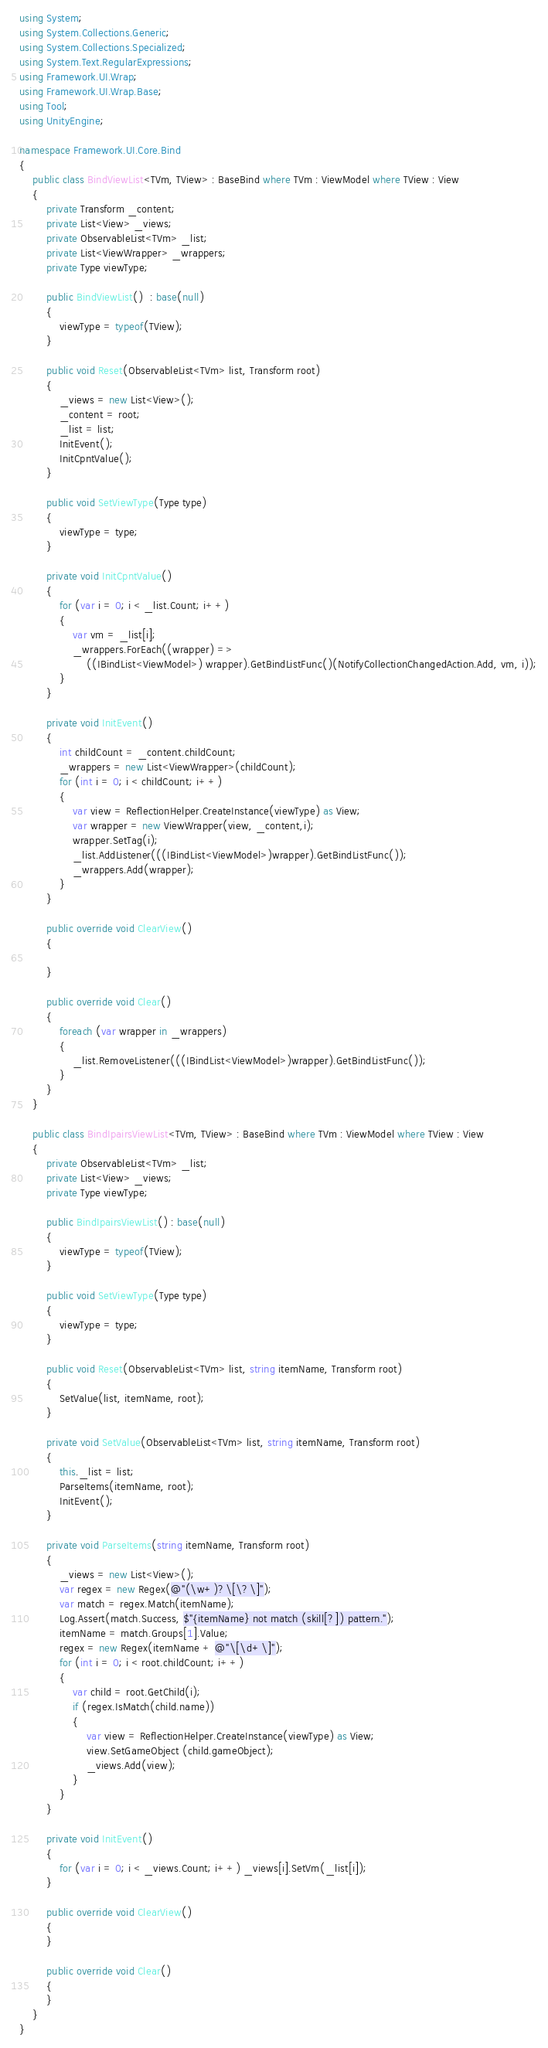<code> <loc_0><loc_0><loc_500><loc_500><_C#_>using System;
using System.Collections.Generic;
using System.Collections.Specialized;
using System.Text.RegularExpressions;
using Framework.UI.Wrap;
using Framework.UI.Wrap.Base;
using Tool;
using UnityEngine;

namespace Framework.UI.Core.Bind
{
    public class BindViewList<TVm, TView> : BaseBind where TVm : ViewModel where TView : View
    {
        private Transform _content;
        private List<View> _views;
        private ObservableList<TVm> _list;
        private List<ViewWrapper> _wrappers;
        private Type viewType;

        public BindViewList()  : base(null)
        {
            viewType = typeof(TView);
        }

        public void Reset(ObservableList<TVm> list, Transform root)
        {
            _views = new List<View>();
            _content = root;
            _list = list;
            InitEvent();
            InitCpntValue(); 
        }

        public void SetViewType(Type type)
        {
            viewType = type;
        }

        private void InitCpntValue()
        {
            for (var i = 0; i < _list.Count; i++)
            {
                var vm = _list[i];
                _wrappers.ForEach((wrapper) =>
                    ((IBindList<ViewModel>) wrapper).GetBindListFunc()(NotifyCollectionChangedAction.Add, vm, i));
            }
        }

        private void InitEvent()
        {
            int childCount = _content.childCount;
            _wrappers = new List<ViewWrapper>(childCount);
            for (int i = 0; i < childCount; i++)
            {
                var view = ReflectionHelper.CreateInstance(viewType) as View;
                var wrapper = new ViewWrapper(view, _content,i);
                wrapper.SetTag(i);
                _list.AddListener(((IBindList<ViewModel>)wrapper).GetBindListFunc());
                _wrappers.Add(wrapper);
            }
        }
        
        public override void ClearView()
        {
            
        }

        public override void Clear()
        {
            foreach (var wrapper in _wrappers)
            {
                _list.RemoveListener(((IBindList<ViewModel>)wrapper).GetBindListFunc());
            }
        }
    }

    public class BindIpairsViewList<TVm, TView> : BaseBind where TVm : ViewModel where TView : View
    {
        private ObservableList<TVm> _list;
        private List<View> _views;
        private Type viewType;
        
        public BindIpairsViewList() : base(null)
        {
            viewType = typeof(TView);
        }
        
        public void SetViewType(Type type)
        {
            viewType = type;
        }

        public void Reset(ObservableList<TVm> list, string itemName, Transform root)
        {
            SetValue(list, itemName, root);
        }

        private void SetValue(ObservableList<TVm> list, string itemName, Transform root)
        {
            this._list = list;
            ParseItems(itemName, root);
            InitEvent();
        }

        private void ParseItems(string itemName, Transform root)
        {
            _views = new List<View>();
            var regex = new Regex(@"(\w+)?\[\?\]");
            var match = regex.Match(itemName);
            Log.Assert(match.Success, $"{itemName} not match (skill[?]) pattern.");
            itemName = match.Groups[1].Value;
            regex = new Regex(itemName + @"\[\d+\]");
            for (int i = 0; i < root.childCount; i++)
            {
                var child = root.GetChild(i);
                if (regex.IsMatch(child.name))
                {
                    var view = ReflectionHelper.CreateInstance(viewType) as View;
                    view.SetGameObject (child.gameObject);
                    _views.Add(view);
                }
            }
        }

        private void InitEvent()
        {
            for (var i = 0; i < _views.Count; i++) _views[i].SetVm(_list[i]);
        }

        public override void ClearView()
        {
        }

        public override void Clear()
        {
        }
    }
}</code> 